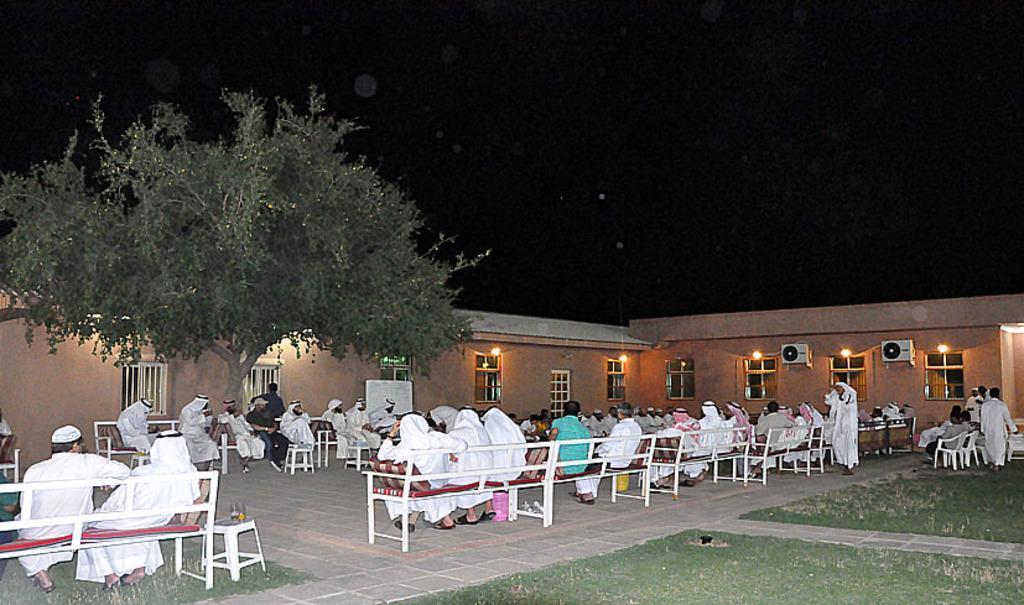Please provide a concise description of this image. There are people sitting on the tables as we can see at the bottom of this image. We can see a building and a tree in the middle of this image. It is dark at the top of this image. 